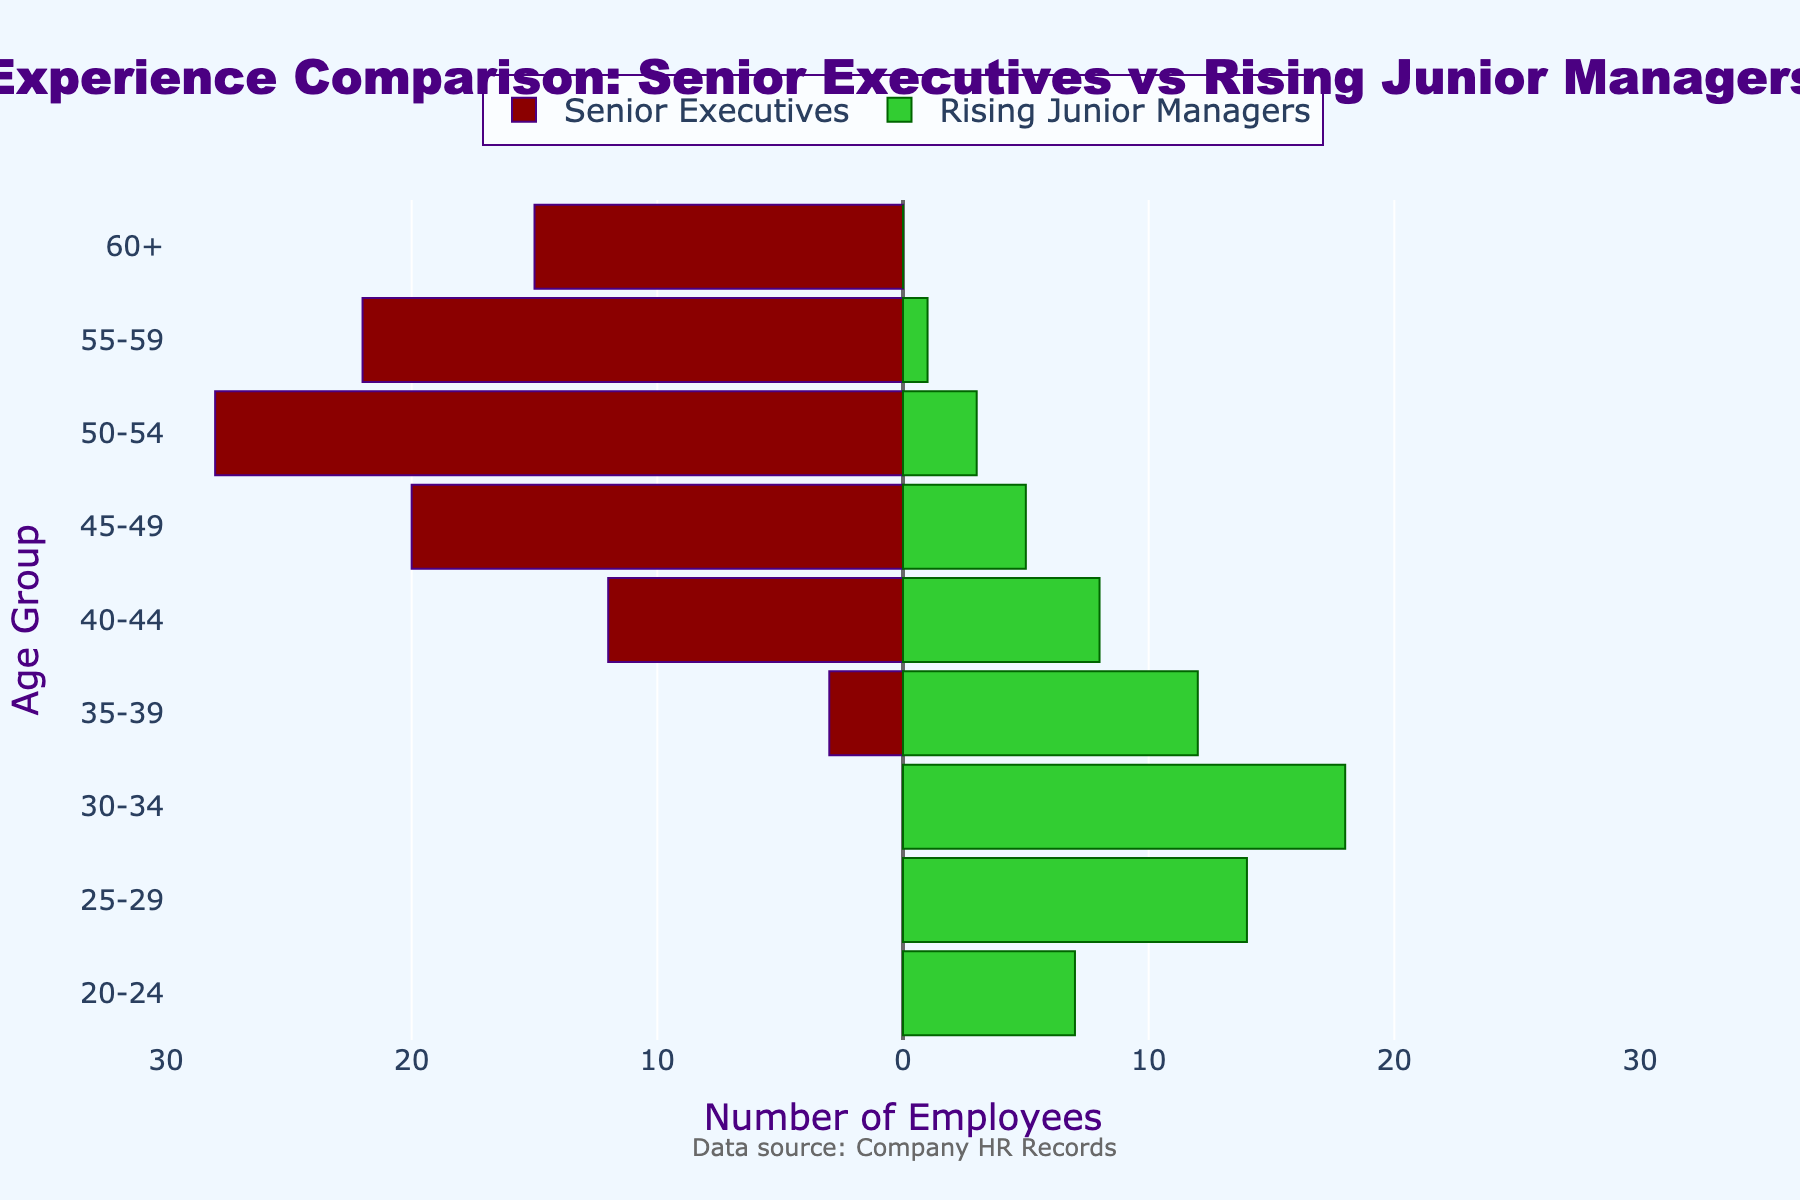What is the title of the visualization? The title is clearly displayed at the top of the figure.
Answer: Experience Comparison: Senior Executives vs Rising Junior Managers How many age groups have senior executives but no rising junior managers? Identify the bars for senior executives without corresponding rising junior manager bars.
Answer: Three age groups (60+, 55-59, 50-54) Which age group has the maximum number of senior executives? Look at the negative x-axis and find the longest bar on the left.
Answer: 50-54 How many rising junior managers are there in the 40-44 age group compared to senior executives? Compare the lengths of the bars for both categories in the 40-44 age group.
Answer: 8 rising junior managers and 12 senior executives In which age group do rising junior managers outnumber senior executives the most? Find the age group with the widest gap on the positive side compared to the negative side.
Answer: 30-34 What is the total number of senior executives aged 45 and above? Sum the values for the age groups 60+, 55-59, 50-54, and 45-49.
Answer: 85 How many total people are in the youngest age group for rising junior managers? Look at the value for rising junior managers in the 20-24 age group.
Answer: 7 Which age group shows the largest discrepancy in numbers between senior executives and rising junior managers? Identify the age group with the largest difference in bar lengths.
Answer: 30-34 How does the number of rising junior managers in the 35-39 age group compare to those in the 50-54 age group? Compare the bar lengths for the 35-39 and 50-54 age groups on the positive x-axis.
Answer: 35-39 has 12 and 50-54 has 3 Which age group has the closest number of senior executives and rising junior managers? Look for bars of similar lengths on either side.
Answer: 40-44 